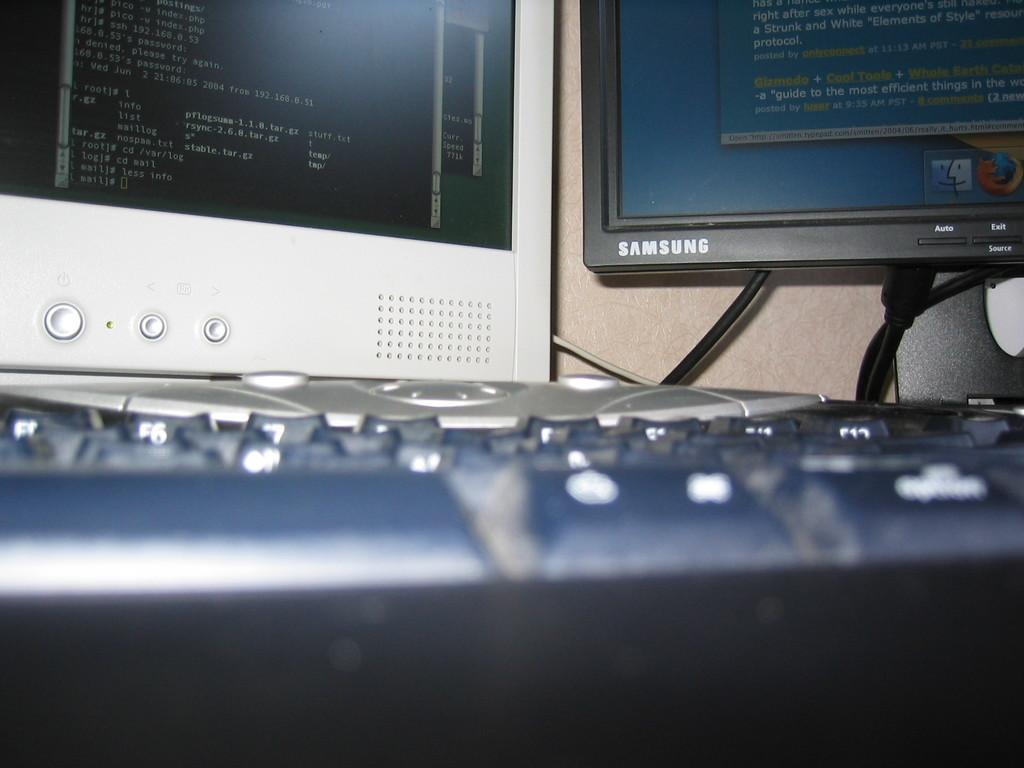What is the main object in the image? There is a keyboard in the image. What can be seen in the background of the image? There are white and black color screens in the background of the image. How many buckets are visible in the image? There are no buckets present in the image. What type of key is used to unlock the keyboard in the image? The image does not show a lock or key for the keyboard, as keyboards typically do not require keys for operation. 